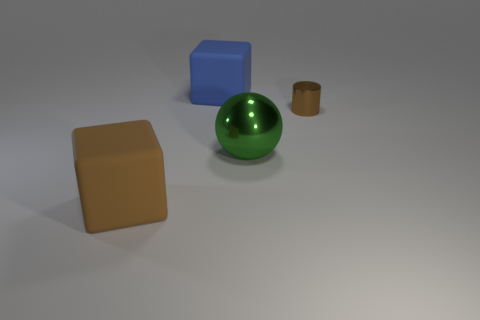Add 3 small yellow metallic cylinders. How many objects exist? 7 Subtract all purple blocks. Subtract all brown spheres. How many blocks are left? 2 Subtract all balls. How many objects are left? 3 Subtract all yellow cylinders. Subtract all blue things. How many objects are left? 3 Add 1 brown things. How many brown things are left? 3 Add 4 big blue objects. How many big blue objects exist? 5 Subtract 0 red cylinders. How many objects are left? 4 